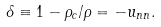<formula> <loc_0><loc_0><loc_500><loc_500>\delta \equiv 1 - \rho _ { c } / \rho = - u _ { n n } .</formula> 